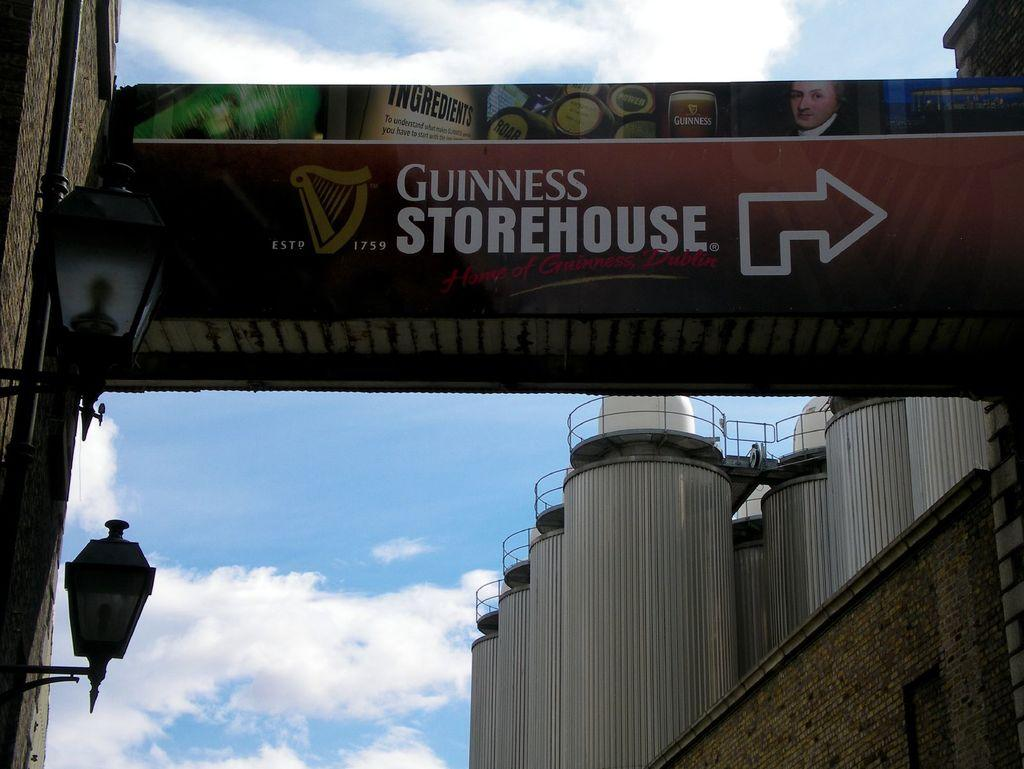Provide a one-sentence caption for the provided image. The sign hanging next to a building informs that the Guinness Storehouse is to the right. 